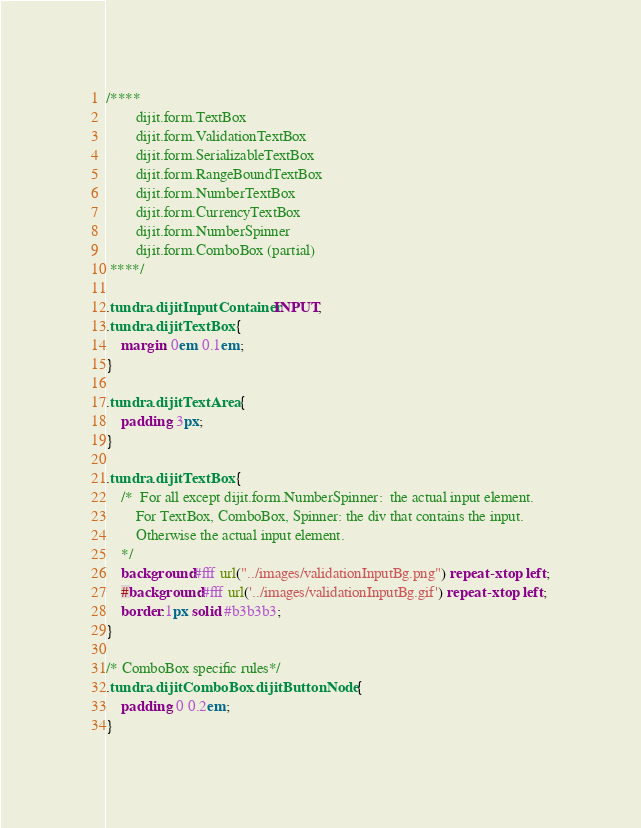<code> <loc_0><loc_0><loc_500><loc_500><_CSS_>
/****
		dijit.form.TextBox
		dijit.form.ValidationTextBox
		dijit.form.SerializableTextBox
		dijit.form.RangeBoundTextBox
		dijit.form.NumberTextBox
		dijit.form.CurrencyTextBox
		dijit.form.NumberSpinner
		dijit.form.ComboBox (partial)
 ****/

.tundra .dijitInputContainer INPUT,
.tundra .dijitTextBox {
	margin: 0em 0.1em;
}

.tundra .dijitTextArea {
	padding: 3px;
}

.tundra .dijitTextBox {
	/* 	For all except dijit.form.NumberSpinner:  the actual input element.
		For TextBox, ComboBox, Spinner: the div that contains the input.
		Otherwise the actual input element.
	*/
	background:#fff url("../images/validationInputBg.png") repeat-x top left;
	#background:#fff url('../images/validationInputBg.gif') repeat-x top left;
	border:1px solid #b3b3b3;
}

/* ComboBox specific rules*/
.tundra .dijitComboBox .dijitButtonNode {
	padding: 0 0.2em;
}</code> 